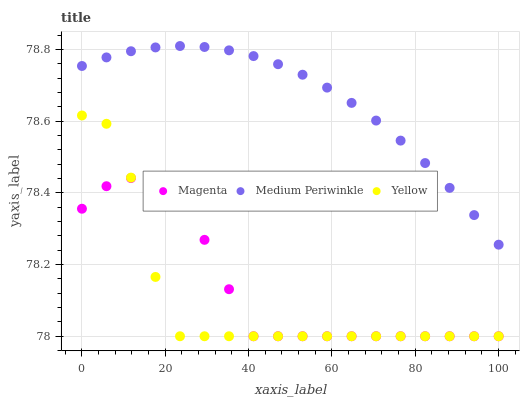Does Yellow have the minimum area under the curve?
Answer yes or no. Yes. Does Medium Periwinkle have the maximum area under the curve?
Answer yes or no. Yes. Does Medium Periwinkle have the minimum area under the curve?
Answer yes or no. No. Does Yellow have the maximum area under the curve?
Answer yes or no. No. Is Medium Periwinkle the smoothest?
Answer yes or no. Yes. Is Yellow the roughest?
Answer yes or no. Yes. Is Yellow the smoothest?
Answer yes or no. No. Is Medium Periwinkle the roughest?
Answer yes or no. No. Does Magenta have the lowest value?
Answer yes or no. Yes. Does Medium Periwinkle have the lowest value?
Answer yes or no. No. Does Medium Periwinkle have the highest value?
Answer yes or no. Yes. Does Yellow have the highest value?
Answer yes or no. No. Is Magenta less than Medium Periwinkle?
Answer yes or no. Yes. Is Medium Periwinkle greater than Yellow?
Answer yes or no. Yes. Does Yellow intersect Magenta?
Answer yes or no. Yes. Is Yellow less than Magenta?
Answer yes or no. No. Is Yellow greater than Magenta?
Answer yes or no. No. Does Magenta intersect Medium Periwinkle?
Answer yes or no. No. 